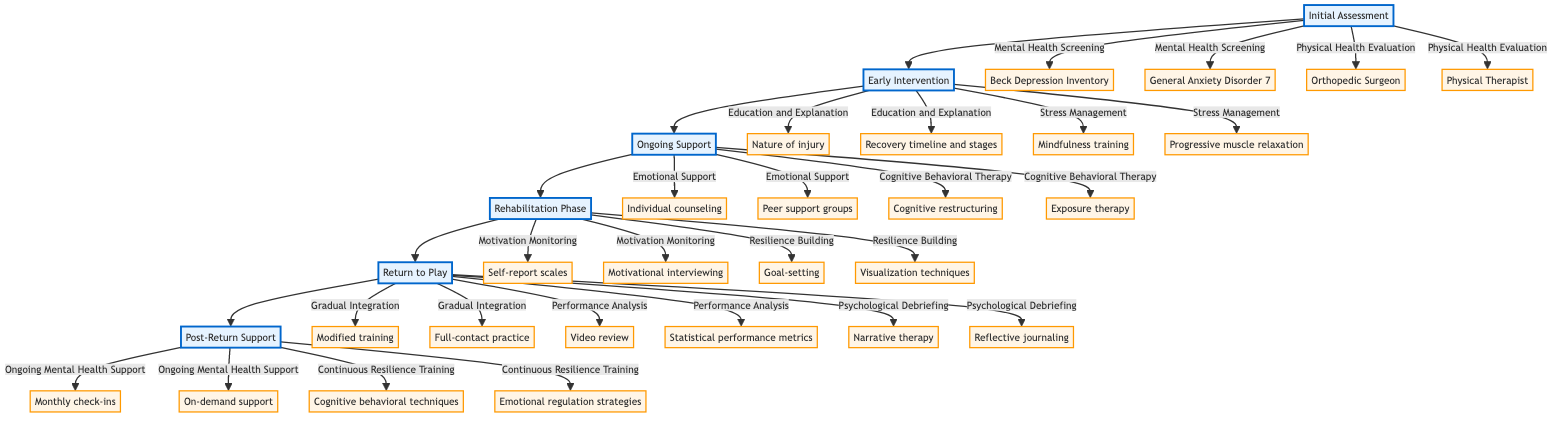What is the first stage in the recovery process? The flowchart starts with the "Initial Assessment" stage, which is the first node in the diagram.
Answer: Initial Assessment How many techniques are listed under Stress Management? There are two techniques shown under the Stress Management section: "Mindfulness training" and "Progressive muscle relaxation." Counting these, we see there are two techniques.
Answer: 2 What is one method used in the Education and Explanation phase? Under the Education and Explanation phase, two methods are mentioned: "One-on-one sessions" and "Educational materials." One method can be selected from these two options.
Answer: One-on-one sessions Which phase follows Ongoing Support? The diagram shows that the "Rehabilitation Phase" directly follows the "Ongoing Support" phase, indicating their sequential relationship in the recovery process.
Answer: Rehabilitation Phase What is the focus area of Cognitive Behavioral Therapy? Within the "Cognitive Behavioral Therapy" section, two focus areas are specified: "Catastrophic thinking" and "Fear of re-injury," indicating the counseling focus during this support phase.
Answer: Catastrophic thinking What types of analysis are included in the Performance Analysis stage? The "Performance Analysis" stage includes two methods: "Video review" and "Statistical performance metrics," providing specific analytical approaches for performance assessment after recovery.
Answer: Video review and Statistical performance metrics What frequency is mentioned for the Ongoing Mental Health Support? The flowchart specifies two frequencies for the Ongoing Mental Health Support: "Monthly check-ins" and "On-demand support," highlighting when players can receive mental health services post-injury.
Answer: Monthly check-ins and On-demand support Which two types of psychological techniques are part of Continuous Resilience Training? The Continuous Resilience Training phase presents two exercises: "Cognitive behavioral techniques" and "Emotional regulation strategies," indicating the ongoing tools used for resilience building following injury.
Answer: Cognitive behavioral techniques and Emotional regulation strategies How is Psychological Debriefing categorized in relation to Return to Play? Psychological Debriefing falls under the "Return to Play" phase, showing that it is an essential component in the transition of players returning from injury during this stage.
Answer: Return to Play 